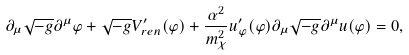Convert formula to latex. <formula><loc_0><loc_0><loc_500><loc_500>\partial _ { \mu } \sqrt { - g } \partial ^ { \mu } \varphi + \sqrt { - g } V _ { r e n } ^ { \prime } ( \varphi ) + { \frac { \alpha ^ { 2 } } { m _ { \chi } ^ { 2 } } } u _ { \varphi } ^ { \prime } ( \varphi ) \partial _ { \mu } \sqrt { - g } \partial ^ { \mu } u ( \varphi ) = 0 ,</formula> 